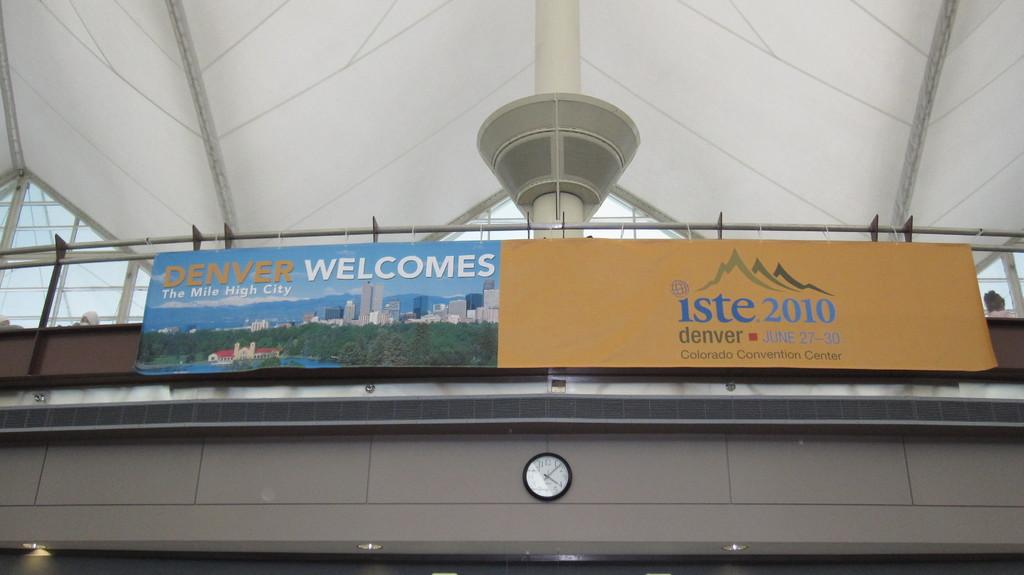Provide a one-sentence caption for the provided image. sme signs saying Denver Welcomes and iste 2010. 